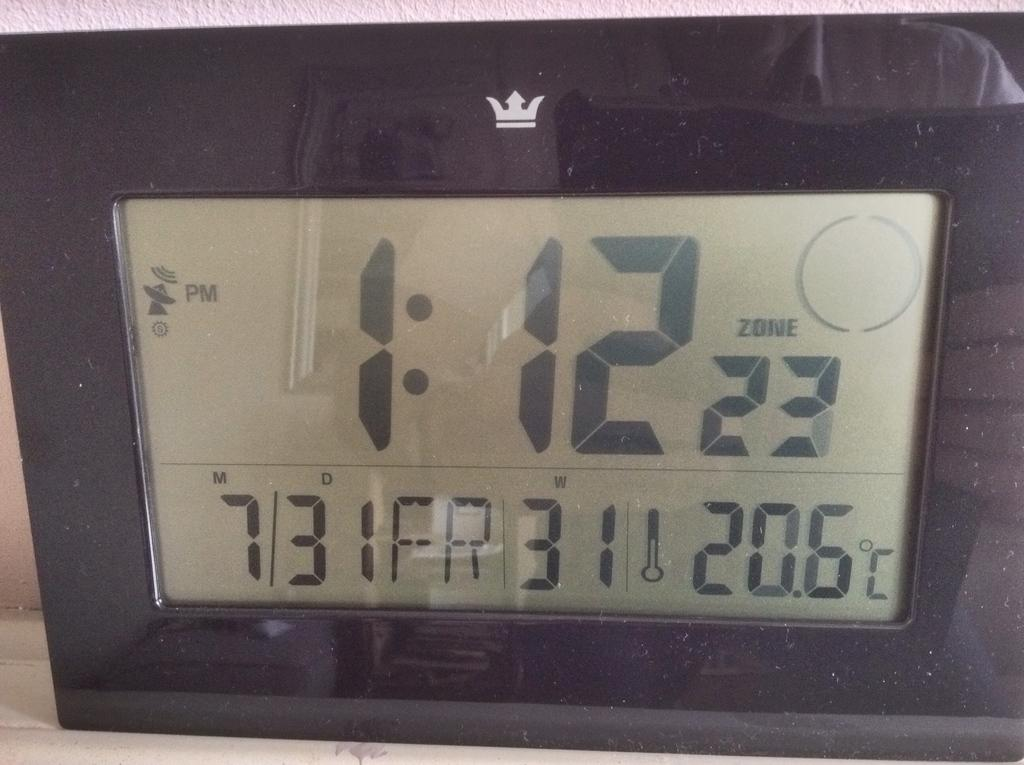Provide a one-sentence caption for the provided image. A digital clock that reads 1:12 and also gives the date below. 